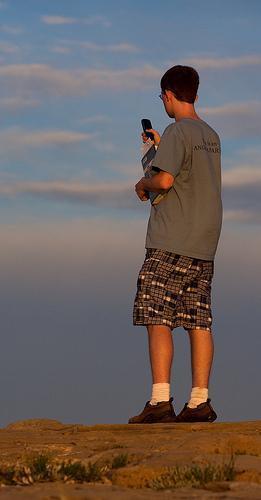How many people are there?
Give a very brief answer. 1. 